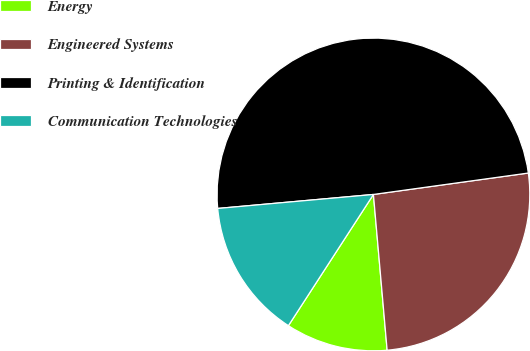Convert chart to OTSL. <chart><loc_0><loc_0><loc_500><loc_500><pie_chart><fcel>Energy<fcel>Engineered Systems<fcel>Printing & Identification<fcel>Communication Technologies<nl><fcel>10.55%<fcel>25.79%<fcel>49.24%<fcel>14.42%<nl></chart> 